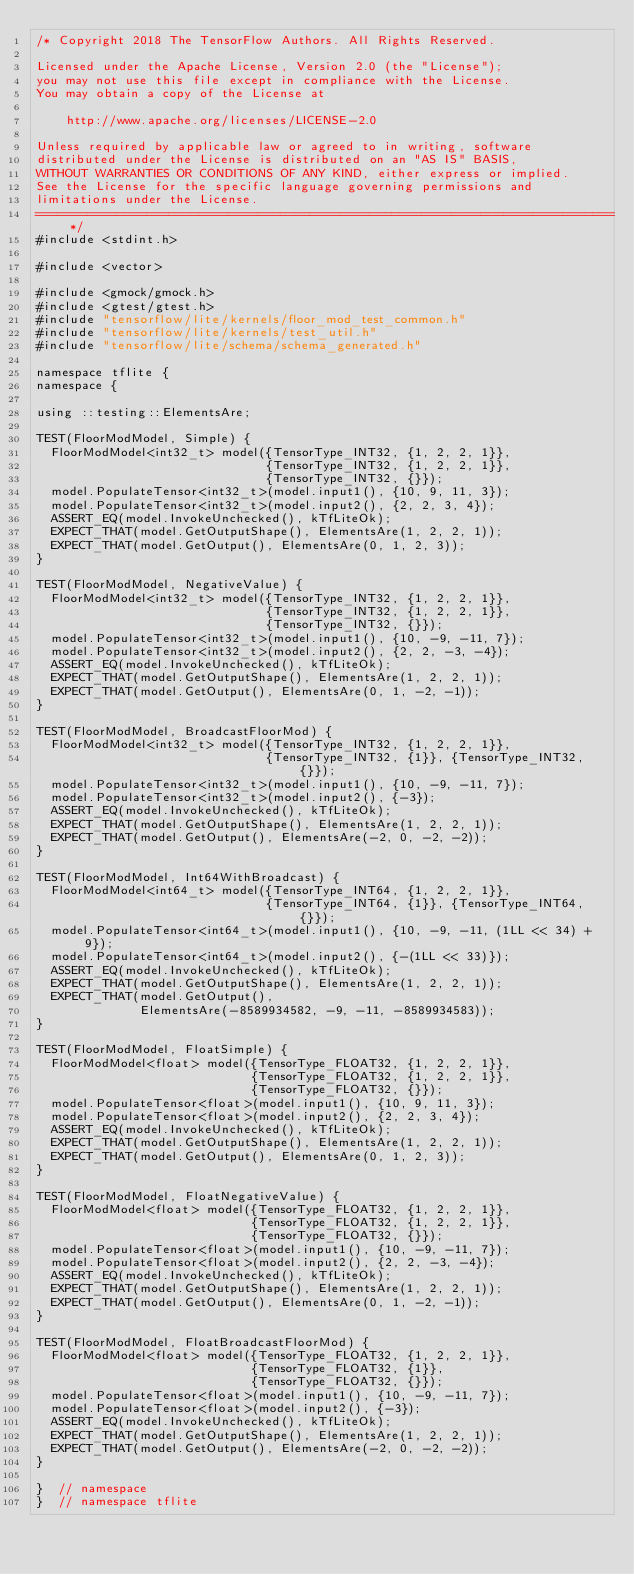Convert code to text. <code><loc_0><loc_0><loc_500><loc_500><_C++_>/* Copyright 2018 The TensorFlow Authors. All Rights Reserved.

Licensed under the Apache License, Version 2.0 (the "License");
you may not use this file except in compliance with the License.
You may obtain a copy of the License at

    http://www.apache.org/licenses/LICENSE-2.0

Unless required by applicable law or agreed to in writing, software
distributed under the License is distributed on an "AS IS" BASIS,
WITHOUT WARRANTIES OR CONDITIONS OF ANY KIND, either express or implied.
See the License for the specific language governing permissions and
limitations under the License.
==============================================================================*/
#include <stdint.h>

#include <vector>

#include <gmock/gmock.h>
#include <gtest/gtest.h>
#include "tensorflow/lite/kernels/floor_mod_test_common.h"
#include "tensorflow/lite/kernels/test_util.h"
#include "tensorflow/lite/schema/schema_generated.h"

namespace tflite {
namespace {

using ::testing::ElementsAre;

TEST(FloorModModel, Simple) {
  FloorModModel<int32_t> model({TensorType_INT32, {1, 2, 2, 1}},
                               {TensorType_INT32, {1, 2, 2, 1}},
                               {TensorType_INT32, {}});
  model.PopulateTensor<int32_t>(model.input1(), {10, 9, 11, 3});
  model.PopulateTensor<int32_t>(model.input2(), {2, 2, 3, 4});
  ASSERT_EQ(model.InvokeUnchecked(), kTfLiteOk);
  EXPECT_THAT(model.GetOutputShape(), ElementsAre(1, 2, 2, 1));
  EXPECT_THAT(model.GetOutput(), ElementsAre(0, 1, 2, 3));
}

TEST(FloorModModel, NegativeValue) {
  FloorModModel<int32_t> model({TensorType_INT32, {1, 2, 2, 1}},
                               {TensorType_INT32, {1, 2, 2, 1}},
                               {TensorType_INT32, {}});
  model.PopulateTensor<int32_t>(model.input1(), {10, -9, -11, 7});
  model.PopulateTensor<int32_t>(model.input2(), {2, 2, -3, -4});
  ASSERT_EQ(model.InvokeUnchecked(), kTfLiteOk);
  EXPECT_THAT(model.GetOutputShape(), ElementsAre(1, 2, 2, 1));
  EXPECT_THAT(model.GetOutput(), ElementsAre(0, 1, -2, -1));
}

TEST(FloorModModel, BroadcastFloorMod) {
  FloorModModel<int32_t> model({TensorType_INT32, {1, 2, 2, 1}},
                               {TensorType_INT32, {1}}, {TensorType_INT32, {}});
  model.PopulateTensor<int32_t>(model.input1(), {10, -9, -11, 7});
  model.PopulateTensor<int32_t>(model.input2(), {-3});
  ASSERT_EQ(model.InvokeUnchecked(), kTfLiteOk);
  EXPECT_THAT(model.GetOutputShape(), ElementsAre(1, 2, 2, 1));
  EXPECT_THAT(model.GetOutput(), ElementsAre(-2, 0, -2, -2));
}

TEST(FloorModModel, Int64WithBroadcast) {
  FloorModModel<int64_t> model({TensorType_INT64, {1, 2, 2, 1}},
                               {TensorType_INT64, {1}}, {TensorType_INT64, {}});
  model.PopulateTensor<int64_t>(model.input1(), {10, -9, -11, (1LL << 34) + 9});
  model.PopulateTensor<int64_t>(model.input2(), {-(1LL << 33)});
  ASSERT_EQ(model.InvokeUnchecked(), kTfLiteOk);
  EXPECT_THAT(model.GetOutputShape(), ElementsAre(1, 2, 2, 1));
  EXPECT_THAT(model.GetOutput(),
              ElementsAre(-8589934582, -9, -11, -8589934583));
}

TEST(FloorModModel, FloatSimple) {
  FloorModModel<float> model({TensorType_FLOAT32, {1, 2, 2, 1}},
                             {TensorType_FLOAT32, {1, 2, 2, 1}},
                             {TensorType_FLOAT32, {}});
  model.PopulateTensor<float>(model.input1(), {10, 9, 11, 3});
  model.PopulateTensor<float>(model.input2(), {2, 2, 3, 4});
  ASSERT_EQ(model.InvokeUnchecked(), kTfLiteOk);
  EXPECT_THAT(model.GetOutputShape(), ElementsAre(1, 2, 2, 1));
  EXPECT_THAT(model.GetOutput(), ElementsAre(0, 1, 2, 3));
}

TEST(FloorModModel, FloatNegativeValue) {
  FloorModModel<float> model({TensorType_FLOAT32, {1, 2, 2, 1}},
                             {TensorType_FLOAT32, {1, 2, 2, 1}},
                             {TensorType_FLOAT32, {}});
  model.PopulateTensor<float>(model.input1(), {10, -9, -11, 7});
  model.PopulateTensor<float>(model.input2(), {2, 2, -3, -4});
  ASSERT_EQ(model.InvokeUnchecked(), kTfLiteOk);
  EXPECT_THAT(model.GetOutputShape(), ElementsAre(1, 2, 2, 1));
  EXPECT_THAT(model.GetOutput(), ElementsAre(0, 1, -2, -1));
}

TEST(FloorModModel, FloatBroadcastFloorMod) {
  FloorModModel<float> model({TensorType_FLOAT32, {1, 2, 2, 1}},
                             {TensorType_FLOAT32, {1}},
                             {TensorType_FLOAT32, {}});
  model.PopulateTensor<float>(model.input1(), {10, -9, -11, 7});
  model.PopulateTensor<float>(model.input2(), {-3});
  ASSERT_EQ(model.InvokeUnchecked(), kTfLiteOk);
  EXPECT_THAT(model.GetOutputShape(), ElementsAre(1, 2, 2, 1));
  EXPECT_THAT(model.GetOutput(), ElementsAre(-2, 0, -2, -2));
}

}  // namespace
}  // namespace tflite
</code> 